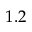Convert formula to latex. <formula><loc_0><loc_0><loc_500><loc_500>1 . 2</formula> 